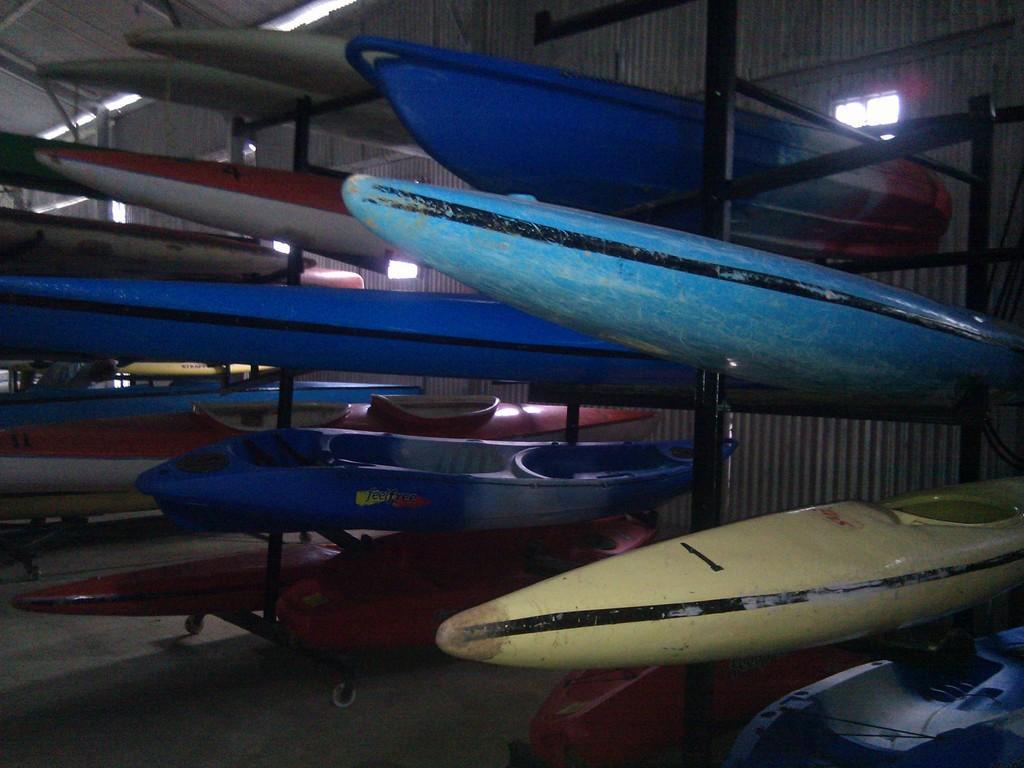Please provide a concise description of this image. In this image there are some kayaking boards are kept in middle of this image and there is a wall in the background. 